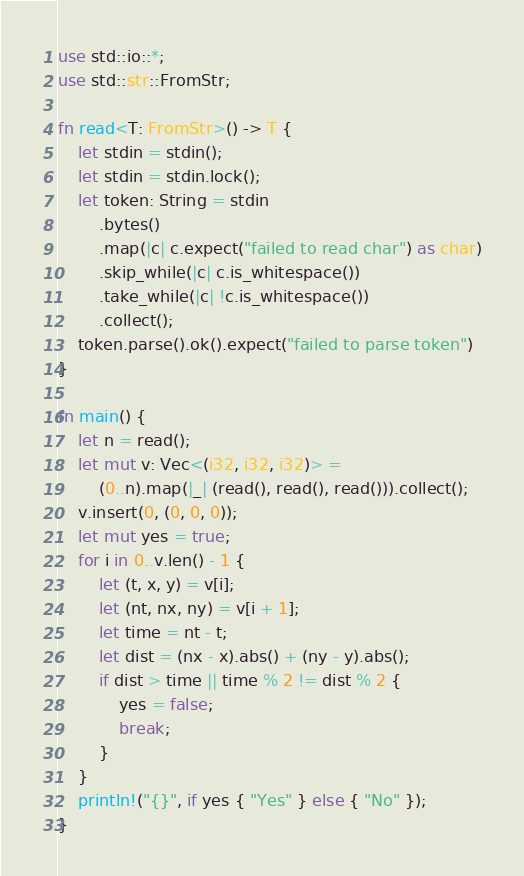<code> <loc_0><loc_0><loc_500><loc_500><_Rust_>use std::io::*;
use std::str::FromStr;

fn read<T: FromStr>() -> T {
    let stdin = stdin();
    let stdin = stdin.lock();
    let token: String = stdin
        .bytes()
        .map(|c| c.expect("failed to read char") as char)
        .skip_while(|c| c.is_whitespace())
        .take_while(|c| !c.is_whitespace())
        .collect();
    token.parse().ok().expect("failed to parse token")
}

fn main() {
    let n = read();
    let mut v: Vec<(i32, i32, i32)> =
        (0..n).map(|_| (read(), read(), read())).collect();
    v.insert(0, (0, 0, 0));
    let mut yes = true;
    for i in 0..v.len() - 1 {
        let (t, x, y) = v[i];
        let (nt, nx, ny) = v[i + 1];
        let time = nt - t;
        let dist = (nx - x).abs() + (ny - y).abs();
        if dist > time || time % 2 != dist % 2 {
            yes = false;
            break;
        }
    }
    println!("{}", if yes { "Yes" } else { "No" });
}
</code> 